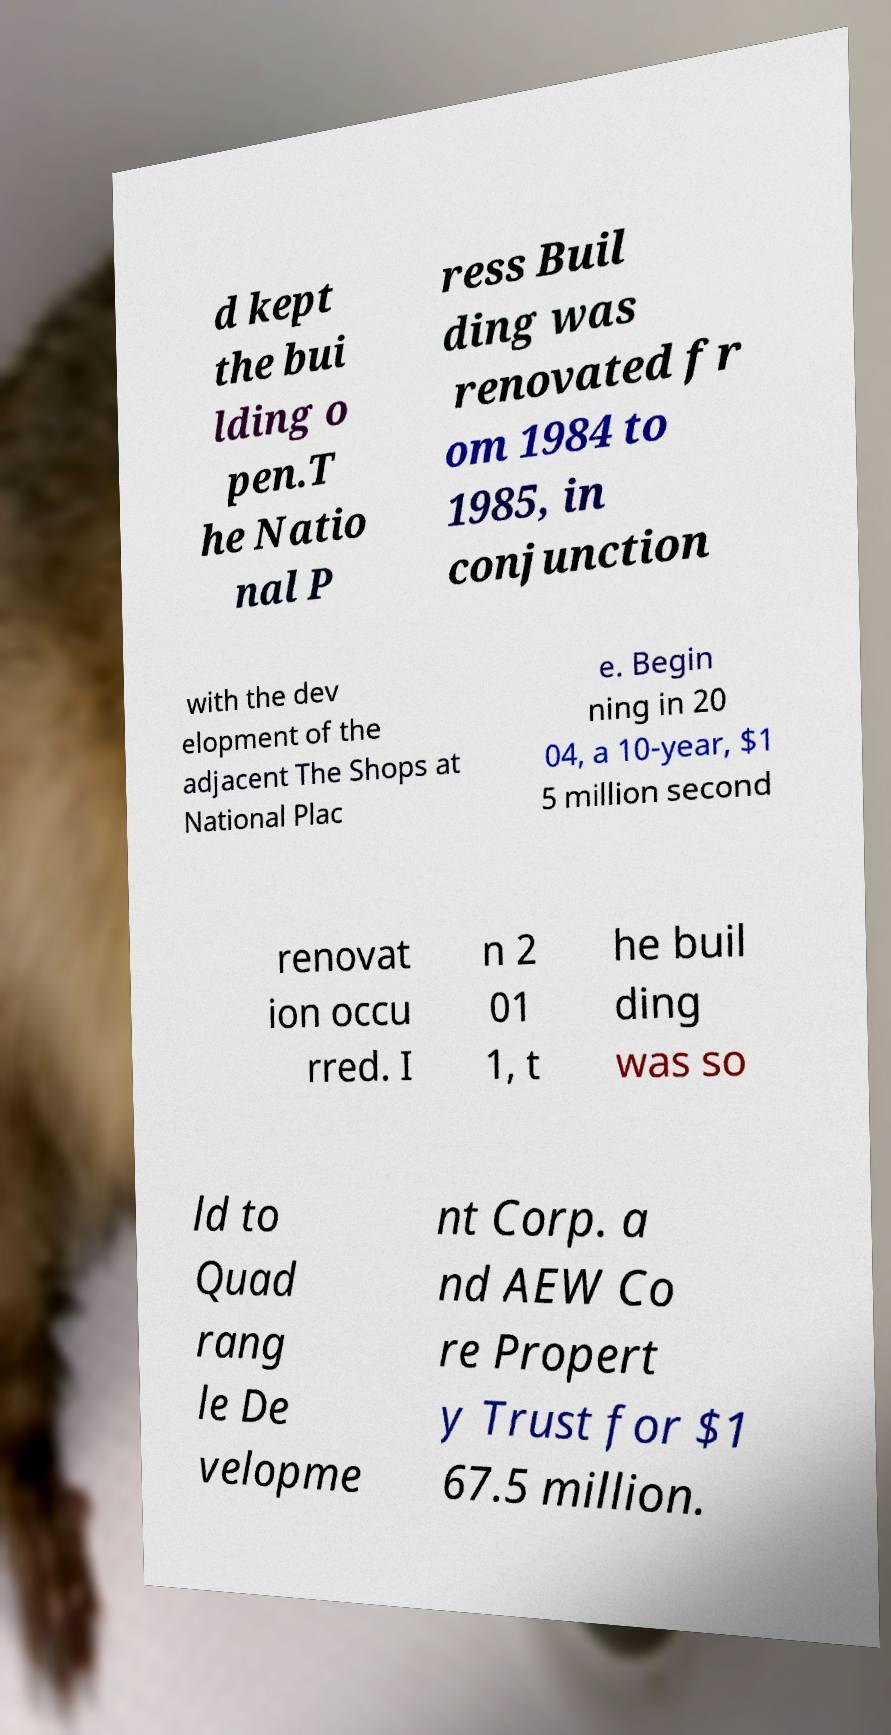Could you assist in decoding the text presented in this image and type it out clearly? d kept the bui lding o pen.T he Natio nal P ress Buil ding was renovated fr om 1984 to 1985, in conjunction with the dev elopment of the adjacent The Shops at National Plac e. Begin ning in 20 04, a 10-year, $1 5 million second renovat ion occu rred. I n 2 01 1, t he buil ding was so ld to Quad rang le De velopme nt Corp. a nd AEW Co re Propert y Trust for $1 67.5 million. 